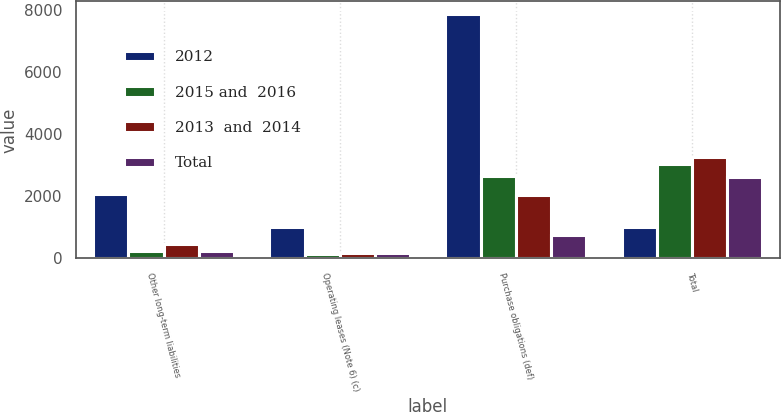<chart> <loc_0><loc_0><loc_500><loc_500><stacked_bar_chart><ecel><fcel>Other long-term liabilities<fcel>Operating leases (Note 6) (c)<fcel>Purchase obligations (def)<fcel>Total<nl><fcel>2012<fcel>2070<fcel>1013<fcel>7868<fcel>1013<nl><fcel>2015 and  2016<fcel>228<fcel>140<fcel>2657<fcel>3025<nl><fcel>2013  and  2014<fcel>459<fcel>187<fcel>2027<fcel>3273<nl><fcel>Total<fcel>222<fcel>169<fcel>759<fcel>2600<nl></chart> 